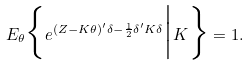Convert formula to latex. <formula><loc_0><loc_0><loc_500><loc_500>E _ { \theta } \Big \{ e ^ { ( Z - K \theta ) ^ { \prime } \delta - \frac { 1 } { 2 } \delta ^ { \prime } K \delta } \Big | K \Big \} = 1 .</formula> 